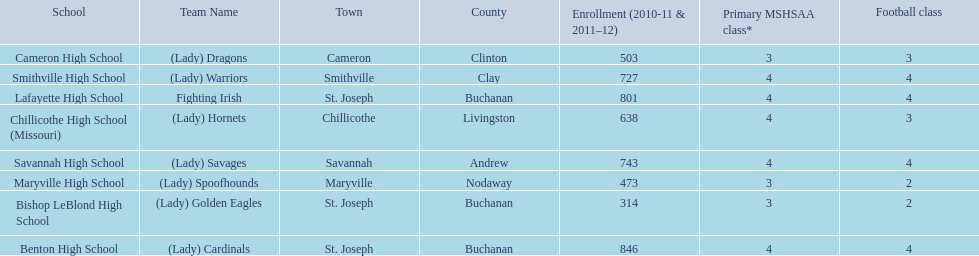How many are enrolled at each school? Benton High School, 846, Bishop LeBlond High School, 314, Cameron High School, 503, Chillicothe High School (Missouri), 638, Lafayette High School, 801, Maryville High School, 473, Savannah High School, 743, Smithville High School, 727. Can you give me this table as a dict? {'header': ['School', 'Team Name', 'Town', 'County', 'Enrollment (2010-11 & 2011–12)', 'Primary MSHSAA class*', 'Football class'], 'rows': [['Cameron High School', '(Lady) Dragons', 'Cameron', 'Clinton', '503', '3', '3'], ['Smithville High School', '(Lady) Warriors', 'Smithville', 'Clay', '727', '4', '4'], ['Lafayette High School', 'Fighting Irish', 'St. Joseph', 'Buchanan', '801', '4', '4'], ['Chillicothe High School (Missouri)', '(Lady) Hornets', 'Chillicothe', 'Livingston', '638', '4', '3'], ['Savannah High School', '(Lady) Savages', 'Savannah', 'Andrew', '743', '4', '4'], ['Maryville High School', '(Lady) Spoofhounds', 'Maryville', 'Nodaway', '473', '3', '2'], ['Bishop LeBlond High School', '(Lady) Golden Eagles', 'St. Joseph', 'Buchanan', '314', '3', '2'], ['Benton High School', '(Lady) Cardinals', 'St. Joseph', 'Buchanan', '846', '4', '4']]} Which school has at only three football classes? Cameron High School, 3, Chillicothe High School (Missouri), 3. Which school has 638 enrolled and 3 football classes? Chillicothe High School (Missouri). 